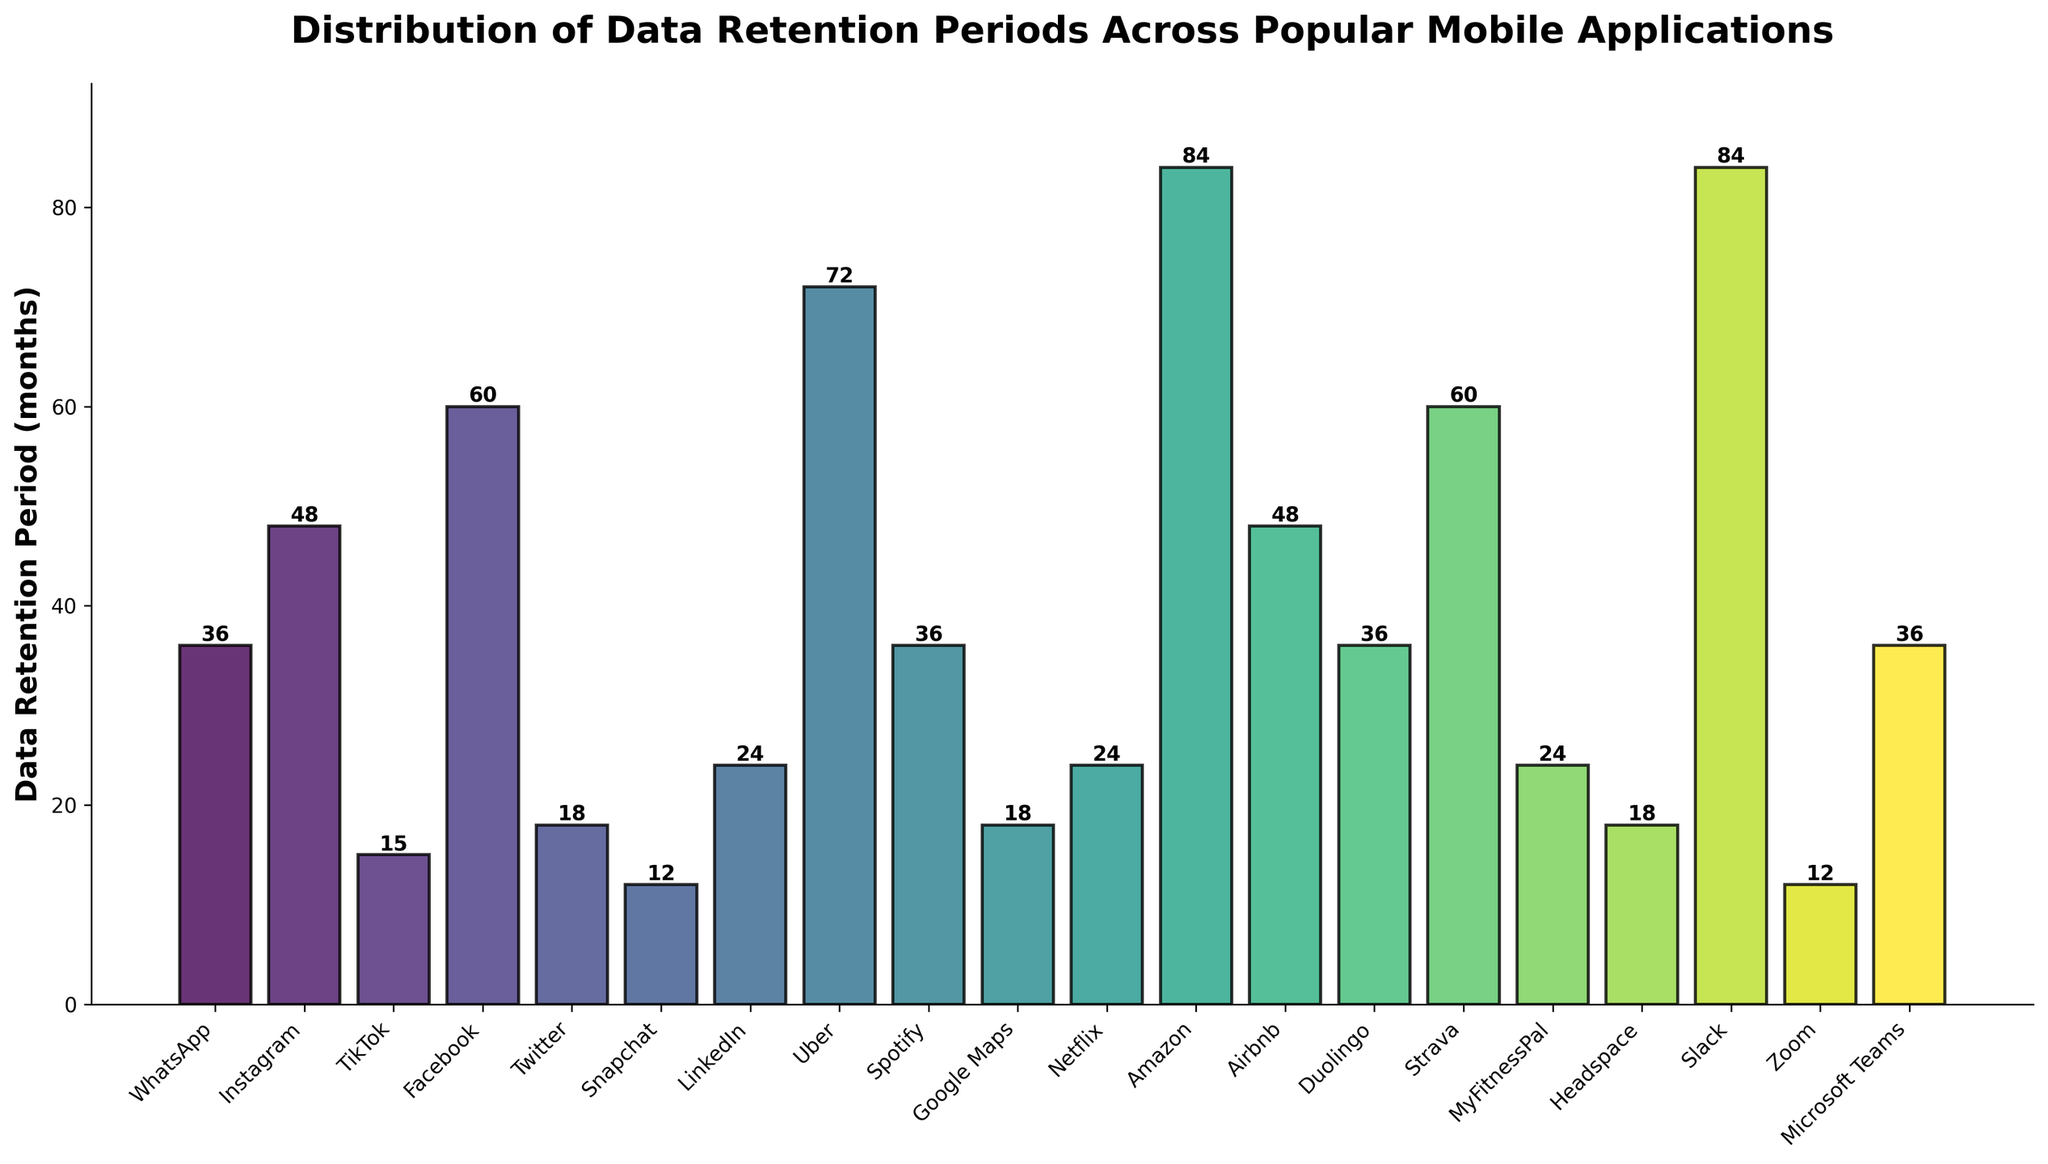Which application has the longest data retention period? First, scan through the heights of the bars in the chart to locate the tallest one. The application with the tallest bar represents the longest data retention period.
Answer: Amazon How many months longer is Uber's data retention period compared to Snapchat's? Find the height of the bars corresponding to Uber and Snapchat. Uber's bar reaches 72 months and Snapchat's bar reaches 12 months. Subtract Snapchat's retention period from Uber's. 72 - 12 = 60
Answer: 60 What is the average data retention period of TikTok, Twitter, and Google Maps? Find the data retention periods for TikTok (15 months), Twitter (18 months), and Google Maps (18 months). Sum these numbers: 15 + 18 + 18 = 51. Divide by 3 (the number of applications): 51 / 3 = 17
Answer: 17 Which application has a data retention period equal to the median value among all applications? First, list all data retention periods and sort them in ascending order: 12, 12, 15, 18, 18, 18, 24, 24, 24, 36, 36, 36, 36, 48, 48, 60, 60, 72, 84, 84. The median is the middle value; for 20 values, take the average of the 10th and 11th values: (36 + 36) / 2 = 36. The application with this period is WhatsApp or Spotify or Duolingo or Microsoft Teams.
Answer: WhatsApp, Spotify, Duolingo, Microsoft Teams Compare the data retention period of Instagram and Facebook. Which one is longer? Identify the bars for Instagram and Facebook. Instagram's bar is at 48 months, and Facebook's bar is at 60 months. Facebook's period is longer.
Answer: Facebook What's the total data retention period if you combine LinkedIn, MyFitnessPal, and Netflix? Find the data retention periods for LinkedIn (24 months), MyFitnessPal (24 months), and Netflix (24 months). Sum these values: 24 + 24 + 24 = 72
Answer: 72 Which applications have a data retention period of 12 months? Locate the bars that reach the 12-month mark. Identify the applications: Snapchat and Zoom.
Answer: Snapchat, Zoom By how many months is the data retention period of Slack different from that of Strava? Find the data retention periods for Slack (84 months) and Strava (60 months). Subtract the smaller value from the larger one: 84 - 60 = 24
Answer: 24 Which applications have data retention periods in ascending order of 15, 18, and 24 months? Identify the bars that reach 15, 18, and 24 months. The applications are TikTok (15), Twitter (18), Google Maps (18), LinkedIn (24), Netflix (24), and MyFitnessPal (24).
Answer: TikTok, Twitter, Google Maps, LinkedIn, Netflix, MyFitnessPal 